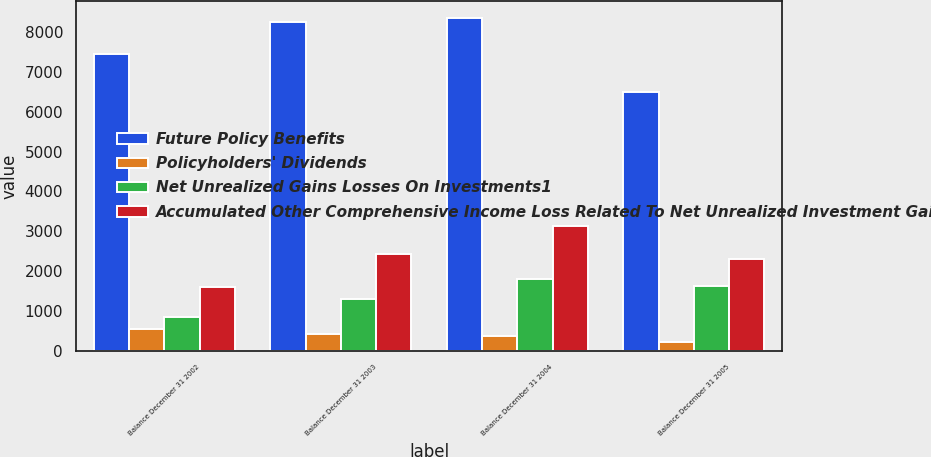<chart> <loc_0><loc_0><loc_500><loc_500><stacked_bar_chart><ecel><fcel>Balance December 31 2002<fcel>Balance December 31 2003<fcel>Balance December 31 2004<fcel>Balance December 31 2005<nl><fcel>Future Policy Benefits<fcel>7446<fcel>8242<fcel>8365<fcel>6499<nl><fcel>Policyholders' Dividends<fcel>536<fcel>433<fcel>372<fcel>220<nl><fcel>Net Unrealized Gains Losses On Investments1<fcel>846<fcel>1292<fcel>1794<fcel>1627<nl><fcel>Accumulated Other Comprehensive Income Loss Related To Net Unrealized Investment Gains Losses<fcel>1606<fcel>2443<fcel>3141<fcel>2302<nl></chart> 